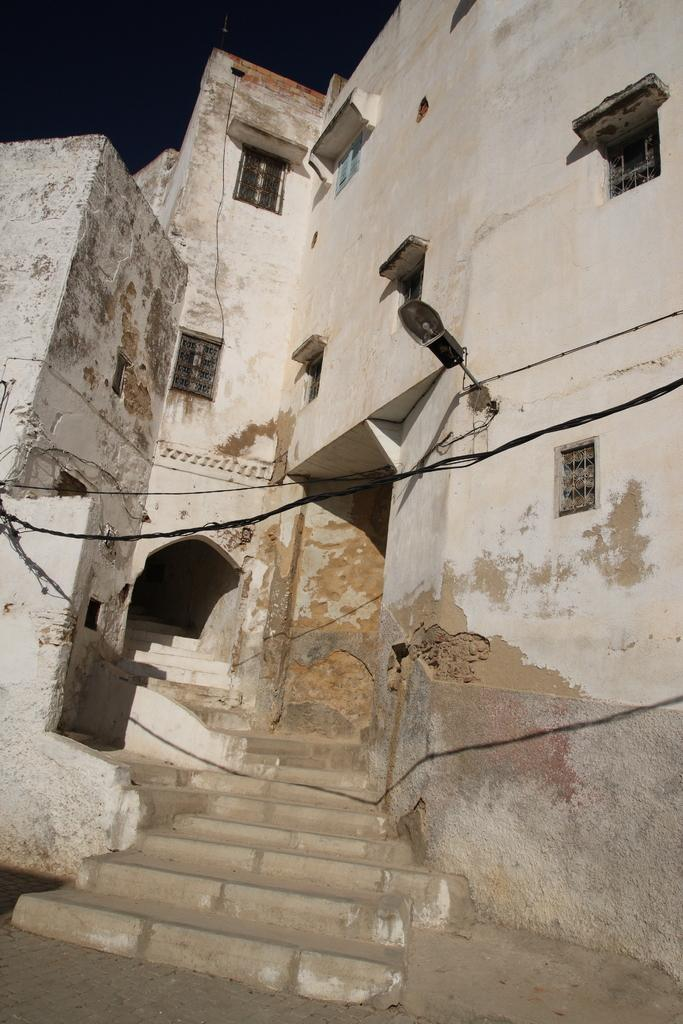What type of structure is visible in the image? There is a building in the image. What feature can be seen on the building? The building has windows. What object is present in the image that provides light? There is a lamp in the image. What type of infrastructure is visible in the image? There are electrical cables in the image. What architectural feature is present in the building? There are staircases in the image. What type of pencil can be seen on the staircase in the image? There is no pencil present in the image; only a building, windows, a lamp, electrical cables, and staircases are visible. 